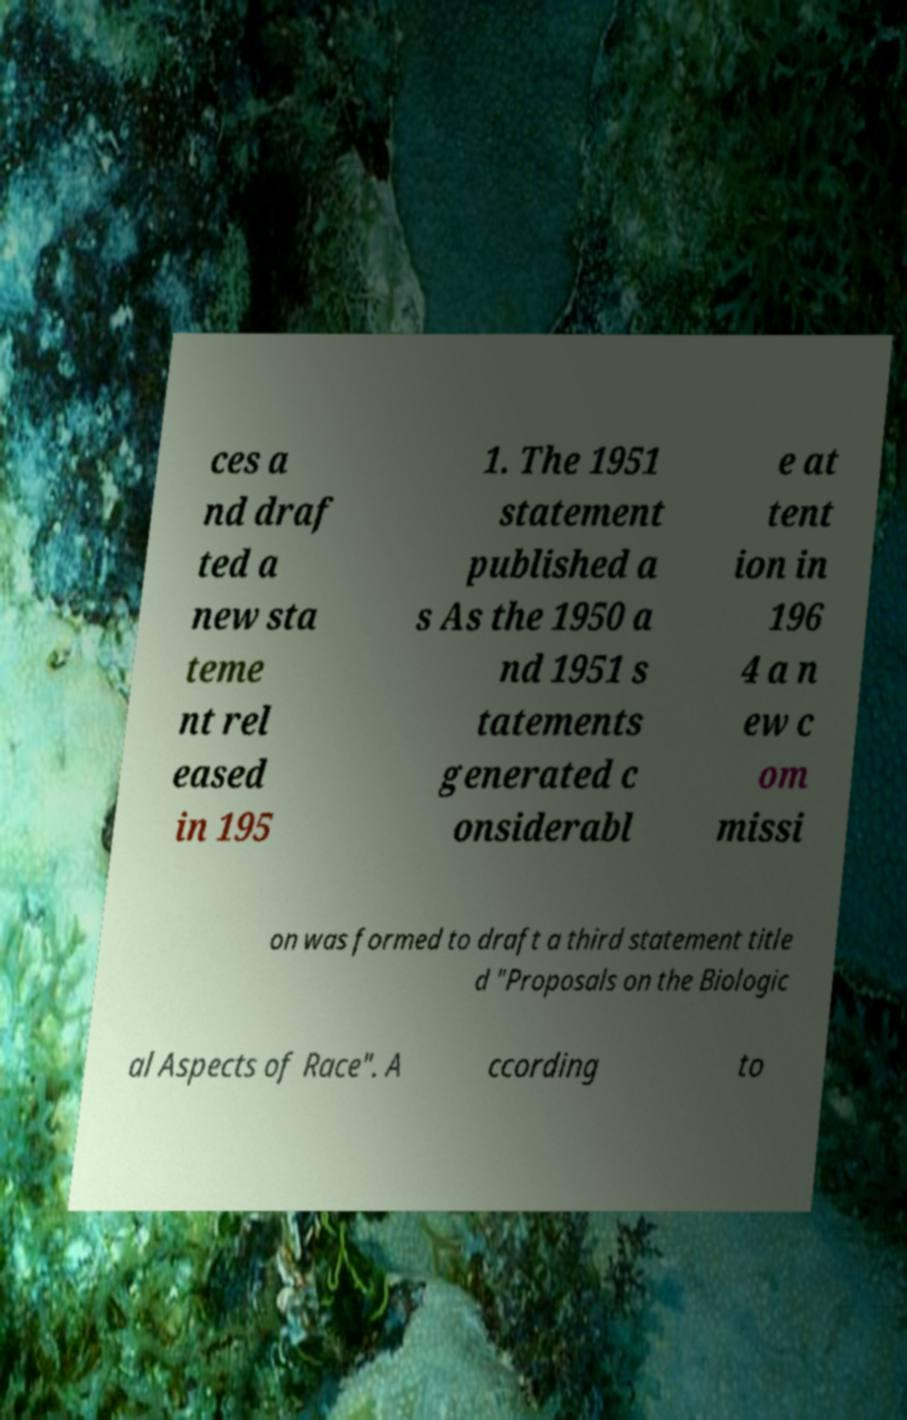Can you accurately transcribe the text from the provided image for me? ces a nd draf ted a new sta teme nt rel eased in 195 1. The 1951 statement published a s As the 1950 a nd 1951 s tatements generated c onsiderabl e at tent ion in 196 4 a n ew c om missi on was formed to draft a third statement title d "Proposals on the Biologic al Aspects of Race". A ccording to 